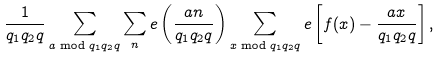<formula> <loc_0><loc_0><loc_500><loc_500>\frac { 1 } { q _ { 1 } q _ { 2 } q } \sum _ { a \bmod { q _ { 1 } q _ { 2 } q } } \sum _ { n } e \left ( \frac { a n } { q _ { 1 } q _ { 2 } q } \right ) \sum _ { x \bmod { q _ { 1 } q _ { 2 } q } } e \left [ f ( x ) - \frac { a x } { q _ { 1 } q _ { 2 } q } \right ] ,</formula> 